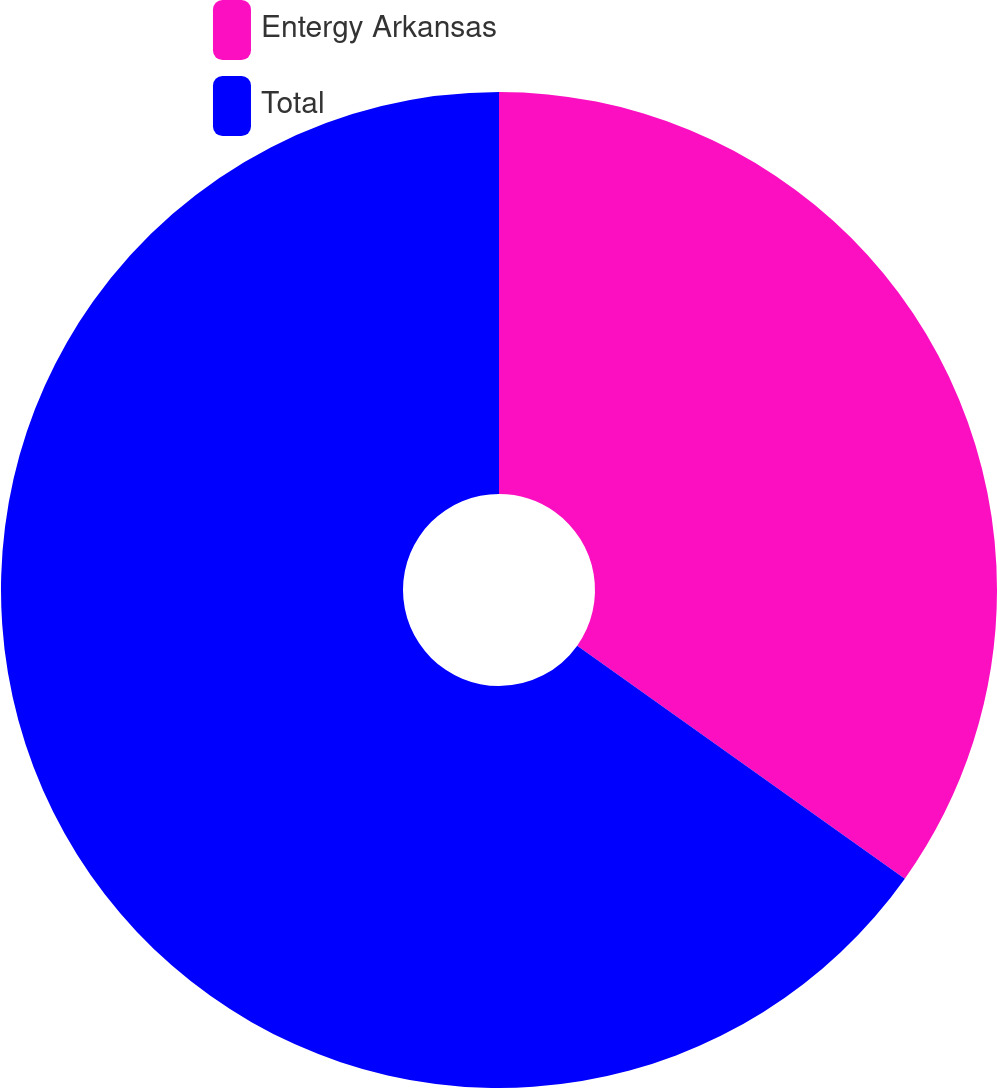Convert chart to OTSL. <chart><loc_0><loc_0><loc_500><loc_500><pie_chart><fcel>Entergy Arkansas<fcel>Total<nl><fcel>34.84%<fcel>65.16%<nl></chart> 